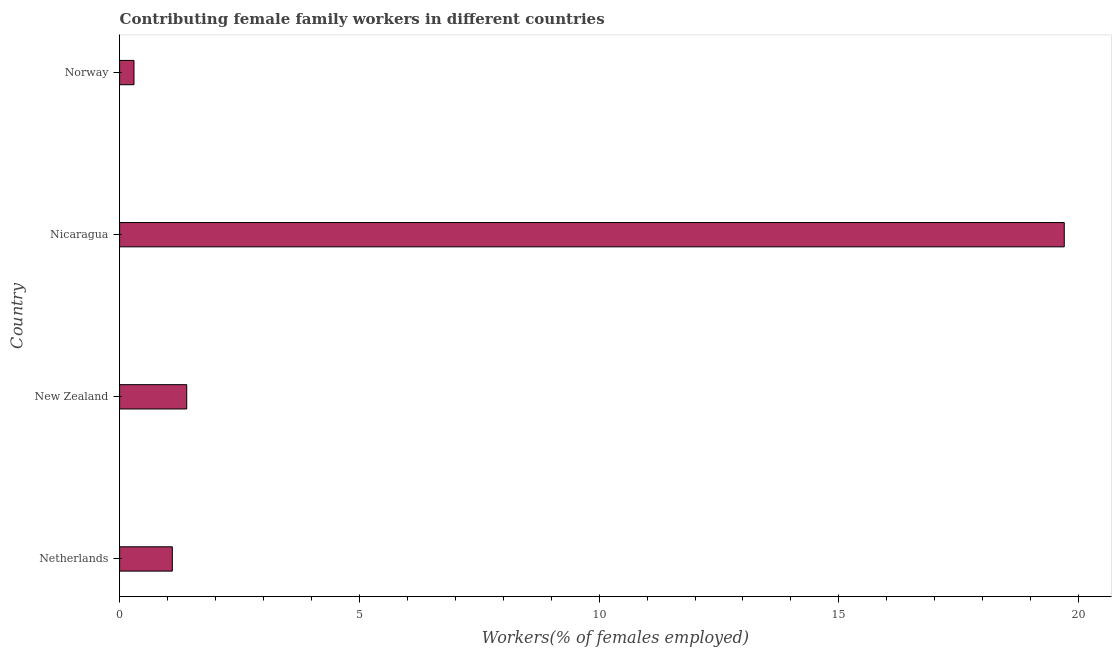Does the graph contain any zero values?
Offer a very short reply. No. What is the title of the graph?
Keep it short and to the point. Contributing female family workers in different countries. What is the label or title of the X-axis?
Your answer should be compact. Workers(% of females employed). What is the contributing female family workers in Nicaragua?
Your answer should be very brief. 19.7. Across all countries, what is the maximum contributing female family workers?
Give a very brief answer. 19.7. Across all countries, what is the minimum contributing female family workers?
Make the answer very short. 0.3. In which country was the contributing female family workers maximum?
Your answer should be very brief. Nicaragua. What is the sum of the contributing female family workers?
Make the answer very short. 22.5. What is the difference between the contributing female family workers in Netherlands and Nicaragua?
Your answer should be compact. -18.6. What is the average contributing female family workers per country?
Your answer should be very brief. 5.62. What is the median contributing female family workers?
Offer a terse response. 1.25. In how many countries, is the contributing female family workers greater than 16 %?
Your answer should be compact. 1. What is the ratio of the contributing female family workers in Nicaragua to that in Norway?
Provide a succinct answer. 65.67. Is the contributing female family workers in Netherlands less than that in Norway?
Provide a succinct answer. No. Is the difference between the contributing female family workers in Netherlands and New Zealand greater than the difference between any two countries?
Keep it short and to the point. No. How many countries are there in the graph?
Provide a succinct answer. 4. What is the difference between two consecutive major ticks on the X-axis?
Provide a succinct answer. 5. What is the Workers(% of females employed) in Netherlands?
Your answer should be compact. 1.1. What is the Workers(% of females employed) in New Zealand?
Provide a succinct answer. 1.4. What is the Workers(% of females employed) in Nicaragua?
Provide a succinct answer. 19.7. What is the Workers(% of females employed) of Norway?
Provide a succinct answer. 0.3. What is the difference between the Workers(% of females employed) in Netherlands and Nicaragua?
Your answer should be compact. -18.6. What is the difference between the Workers(% of females employed) in Netherlands and Norway?
Ensure brevity in your answer.  0.8. What is the difference between the Workers(% of females employed) in New Zealand and Nicaragua?
Your answer should be compact. -18.3. What is the difference between the Workers(% of females employed) in New Zealand and Norway?
Offer a very short reply. 1.1. What is the difference between the Workers(% of females employed) in Nicaragua and Norway?
Give a very brief answer. 19.4. What is the ratio of the Workers(% of females employed) in Netherlands to that in New Zealand?
Give a very brief answer. 0.79. What is the ratio of the Workers(% of females employed) in Netherlands to that in Nicaragua?
Keep it short and to the point. 0.06. What is the ratio of the Workers(% of females employed) in Netherlands to that in Norway?
Ensure brevity in your answer.  3.67. What is the ratio of the Workers(% of females employed) in New Zealand to that in Nicaragua?
Provide a short and direct response. 0.07. What is the ratio of the Workers(% of females employed) in New Zealand to that in Norway?
Make the answer very short. 4.67. What is the ratio of the Workers(% of females employed) in Nicaragua to that in Norway?
Keep it short and to the point. 65.67. 